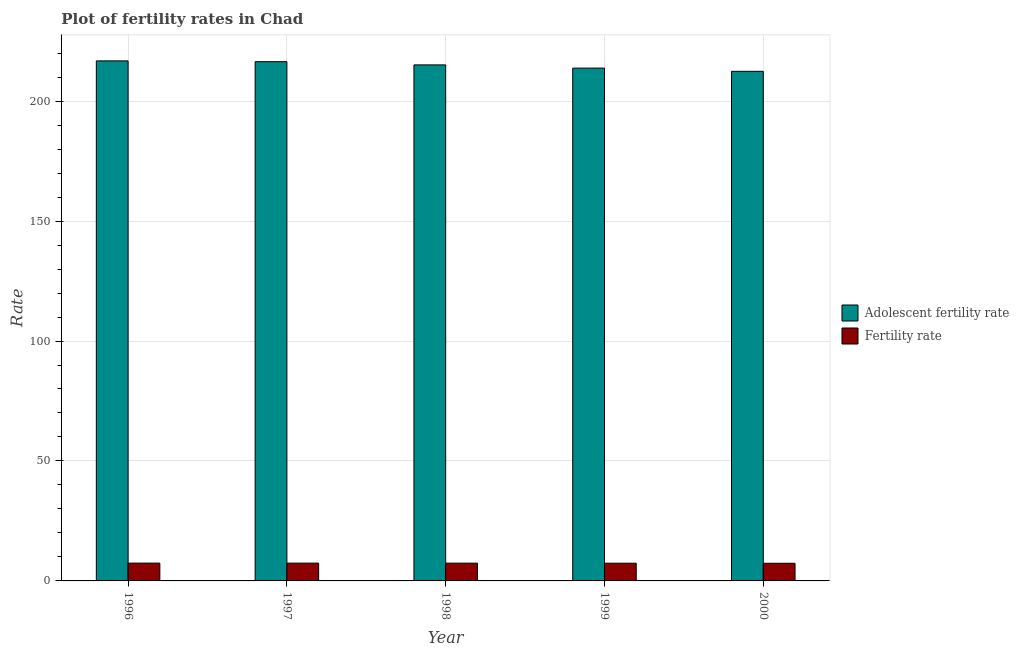How many groups of bars are there?
Make the answer very short. 5. How many bars are there on the 4th tick from the left?
Ensure brevity in your answer.  2. How many bars are there on the 4th tick from the right?
Keep it short and to the point. 2. What is the label of the 1st group of bars from the left?
Ensure brevity in your answer.  1996. In how many cases, is the number of bars for a given year not equal to the number of legend labels?
Ensure brevity in your answer.  0. What is the adolescent fertility rate in 1999?
Keep it short and to the point. 213.75. Across all years, what is the maximum fertility rate?
Provide a succinct answer. 7.43. Across all years, what is the minimum fertility rate?
Offer a very short reply. 7.35. In which year was the fertility rate maximum?
Your answer should be very brief. 1996. What is the total fertility rate in the graph?
Make the answer very short. 36.99. What is the difference between the adolescent fertility rate in 1996 and that in 1999?
Ensure brevity in your answer.  3.01. What is the difference between the fertility rate in 1997 and the adolescent fertility rate in 1999?
Provide a succinct answer. 0.04. What is the average adolescent fertility rate per year?
Your response must be concise. 214.89. In the year 1996, what is the difference between the adolescent fertility rate and fertility rate?
Offer a very short reply. 0. In how many years, is the fertility rate greater than 180?
Provide a short and direct response. 0. What is the ratio of the adolescent fertility rate in 1996 to that in 1998?
Your answer should be compact. 1.01. Is the fertility rate in 1998 less than that in 2000?
Make the answer very short. No. What is the difference between the highest and the second highest fertility rate?
Make the answer very short. 0.01. What is the difference between the highest and the lowest fertility rate?
Give a very brief answer. 0.07. In how many years, is the fertility rate greater than the average fertility rate taken over all years?
Keep it short and to the point. 3. What does the 1st bar from the left in 2000 represents?
Your answer should be very brief. Adolescent fertility rate. What does the 1st bar from the right in 2000 represents?
Offer a terse response. Fertility rate. How many years are there in the graph?
Keep it short and to the point. 5. What is the difference between two consecutive major ticks on the Y-axis?
Keep it short and to the point. 50. Are the values on the major ticks of Y-axis written in scientific E-notation?
Give a very brief answer. No. How many legend labels are there?
Your answer should be compact. 2. What is the title of the graph?
Offer a very short reply. Plot of fertility rates in Chad. What is the label or title of the X-axis?
Provide a short and direct response. Year. What is the label or title of the Y-axis?
Your answer should be compact. Rate. What is the Rate in Adolescent fertility rate in 1996?
Provide a short and direct response. 216.77. What is the Rate of Fertility rate in 1996?
Your answer should be very brief. 7.43. What is the Rate of Adolescent fertility rate in 1997?
Provide a short and direct response. 216.43. What is the Rate in Fertility rate in 1997?
Make the answer very short. 7.42. What is the Rate in Adolescent fertility rate in 1998?
Your answer should be compact. 215.09. What is the Rate of Fertility rate in 1998?
Offer a very short reply. 7.41. What is the Rate of Adolescent fertility rate in 1999?
Provide a succinct answer. 213.75. What is the Rate of Fertility rate in 1999?
Provide a succinct answer. 7.38. What is the Rate in Adolescent fertility rate in 2000?
Provide a short and direct response. 212.41. What is the Rate of Fertility rate in 2000?
Provide a short and direct response. 7.35. Across all years, what is the maximum Rate of Adolescent fertility rate?
Your answer should be very brief. 216.77. Across all years, what is the maximum Rate of Fertility rate?
Provide a succinct answer. 7.43. Across all years, what is the minimum Rate in Adolescent fertility rate?
Make the answer very short. 212.41. Across all years, what is the minimum Rate of Fertility rate?
Provide a succinct answer. 7.35. What is the total Rate of Adolescent fertility rate in the graph?
Provide a short and direct response. 1074.45. What is the total Rate in Fertility rate in the graph?
Your response must be concise. 36.99. What is the difference between the Rate in Adolescent fertility rate in 1996 and that in 1997?
Provide a succinct answer. 0.33. What is the difference between the Rate of Fertility rate in 1996 and that in 1997?
Give a very brief answer. 0.01. What is the difference between the Rate of Adolescent fertility rate in 1996 and that in 1998?
Offer a terse response. 1.67. What is the difference between the Rate of Fertility rate in 1996 and that in 1998?
Offer a very short reply. 0.02. What is the difference between the Rate of Adolescent fertility rate in 1996 and that in 1999?
Give a very brief answer. 3.01. What is the difference between the Rate in Fertility rate in 1996 and that in 1999?
Offer a terse response. 0.04. What is the difference between the Rate of Adolescent fertility rate in 1996 and that in 2000?
Offer a terse response. 4.36. What is the difference between the Rate in Fertility rate in 1996 and that in 2000?
Ensure brevity in your answer.  0.07. What is the difference between the Rate of Adolescent fertility rate in 1997 and that in 1998?
Make the answer very short. 1.34. What is the difference between the Rate in Fertility rate in 1997 and that in 1998?
Your answer should be compact. 0.01. What is the difference between the Rate of Adolescent fertility rate in 1997 and that in 1999?
Offer a very short reply. 2.68. What is the difference between the Rate of Fertility rate in 1997 and that in 1999?
Offer a terse response. 0.04. What is the difference between the Rate in Adolescent fertility rate in 1997 and that in 2000?
Keep it short and to the point. 4.02. What is the difference between the Rate of Fertility rate in 1997 and that in 2000?
Offer a terse response. 0.07. What is the difference between the Rate in Adolescent fertility rate in 1998 and that in 1999?
Ensure brevity in your answer.  1.34. What is the difference between the Rate in Fertility rate in 1998 and that in 1999?
Provide a short and direct response. 0.02. What is the difference between the Rate of Adolescent fertility rate in 1998 and that in 2000?
Give a very brief answer. 2.68. What is the difference between the Rate of Fertility rate in 1998 and that in 2000?
Ensure brevity in your answer.  0.05. What is the difference between the Rate in Adolescent fertility rate in 1999 and that in 2000?
Offer a terse response. 1.34. What is the difference between the Rate in Adolescent fertility rate in 1996 and the Rate in Fertility rate in 1997?
Your answer should be compact. 209.35. What is the difference between the Rate in Adolescent fertility rate in 1996 and the Rate in Fertility rate in 1998?
Your response must be concise. 209.36. What is the difference between the Rate of Adolescent fertility rate in 1996 and the Rate of Fertility rate in 1999?
Provide a succinct answer. 209.38. What is the difference between the Rate in Adolescent fertility rate in 1996 and the Rate in Fertility rate in 2000?
Provide a short and direct response. 209.41. What is the difference between the Rate in Adolescent fertility rate in 1997 and the Rate in Fertility rate in 1998?
Your answer should be compact. 209.03. What is the difference between the Rate in Adolescent fertility rate in 1997 and the Rate in Fertility rate in 1999?
Keep it short and to the point. 209.05. What is the difference between the Rate in Adolescent fertility rate in 1997 and the Rate in Fertility rate in 2000?
Your response must be concise. 209.08. What is the difference between the Rate of Adolescent fertility rate in 1998 and the Rate of Fertility rate in 1999?
Provide a short and direct response. 207.71. What is the difference between the Rate in Adolescent fertility rate in 1998 and the Rate in Fertility rate in 2000?
Your response must be concise. 207.74. What is the difference between the Rate in Adolescent fertility rate in 1999 and the Rate in Fertility rate in 2000?
Offer a very short reply. 206.4. What is the average Rate of Adolescent fertility rate per year?
Your response must be concise. 214.89. What is the average Rate in Fertility rate per year?
Provide a short and direct response. 7.4. In the year 1996, what is the difference between the Rate in Adolescent fertility rate and Rate in Fertility rate?
Ensure brevity in your answer.  209.34. In the year 1997, what is the difference between the Rate of Adolescent fertility rate and Rate of Fertility rate?
Make the answer very short. 209.01. In the year 1998, what is the difference between the Rate of Adolescent fertility rate and Rate of Fertility rate?
Provide a short and direct response. 207.69. In the year 1999, what is the difference between the Rate in Adolescent fertility rate and Rate in Fertility rate?
Your answer should be compact. 206.37. In the year 2000, what is the difference between the Rate in Adolescent fertility rate and Rate in Fertility rate?
Your answer should be very brief. 205.06. What is the ratio of the Rate of Adolescent fertility rate in 1996 to that in 1998?
Your response must be concise. 1.01. What is the ratio of the Rate of Adolescent fertility rate in 1996 to that in 1999?
Offer a very short reply. 1.01. What is the ratio of the Rate of Fertility rate in 1996 to that in 1999?
Offer a terse response. 1.01. What is the ratio of the Rate in Adolescent fertility rate in 1996 to that in 2000?
Make the answer very short. 1.02. What is the ratio of the Rate in Fertility rate in 1996 to that in 2000?
Your answer should be very brief. 1.01. What is the ratio of the Rate in Adolescent fertility rate in 1997 to that in 1998?
Provide a short and direct response. 1.01. What is the ratio of the Rate in Adolescent fertility rate in 1997 to that in 1999?
Provide a succinct answer. 1.01. What is the ratio of the Rate of Fertility rate in 1997 to that in 1999?
Make the answer very short. 1. What is the ratio of the Rate in Adolescent fertility rate in 1997 to that in 2000?
Offer a very short reply. 1.02. What is the ratio of the Rate in Fertility rate in 1997 to that in 2000?
Your answer should be very brief. 1.01. What is the ratio of the Rate of Fertility rate in 1998 to that in 1999?
Your answer should be compact. 1. What is the ratio of the Rate of Adolescent fertility rate in 1998 to that in 2000?
Keep it short and to the point. 1.01. What is the ratio of the Rate in Fertility rate in 1998 to that in 2000?
Keep it short and to the point. 1.01. What is the difference between the highest and the second highest Rate of Adolescent fertility rate?
Offer a terse response. 0.33. What is the difference between the highest and the second highest Rate in Fertility rate?
Offer a very short reply. 0.01. What is the difference between the highest and the lowest Rate of Adolescent fertility rate?
Offer a very short reply. 4.36. What is the difference between the highest and the lowest Rate of Fertility rate?
Keep it short and to the point. 0.07. 